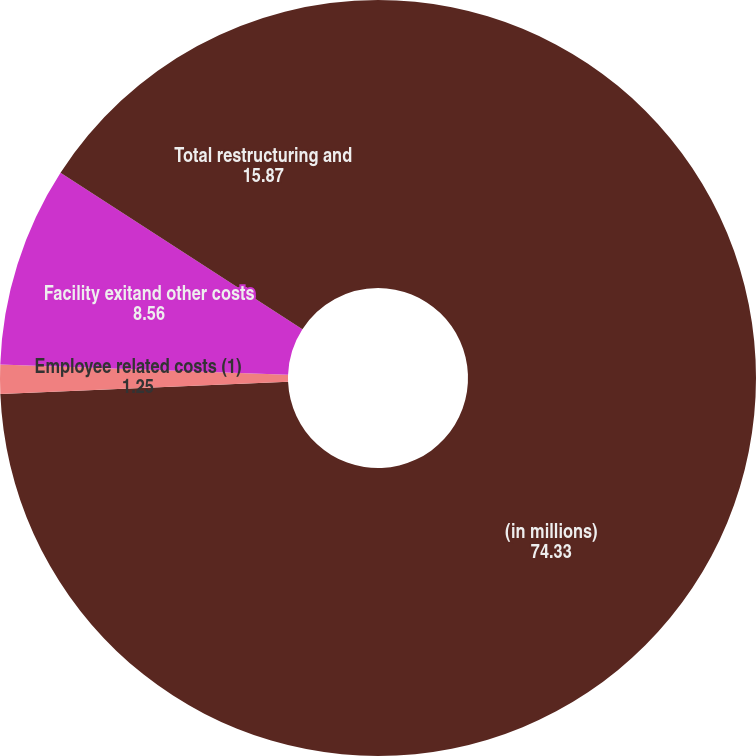Convert chart. <chart><loc_0><loc_0><loc_500><loc_500><pie_chart><fcel>(in millions)<fcel>Employee related costs (1)<fcel>Facility exitand other costs<fcel>Total restructuring and<nl><fcel>74.33%<fcel>1.25%<fcel>8.56%<fcel>15.87%<nl></chart> 